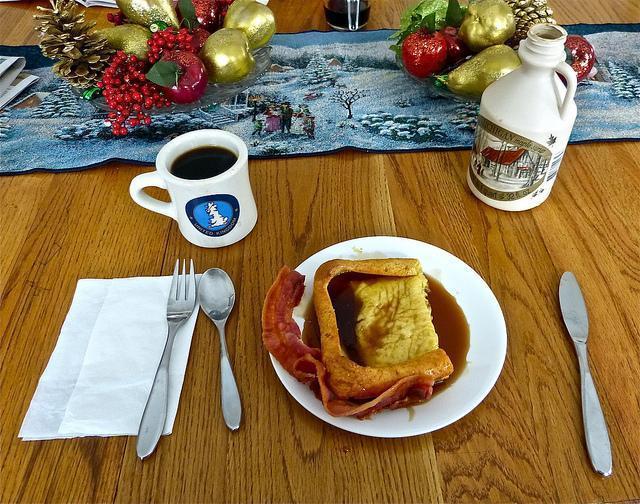How many apples are there?
Give a very brief answer. 2. 